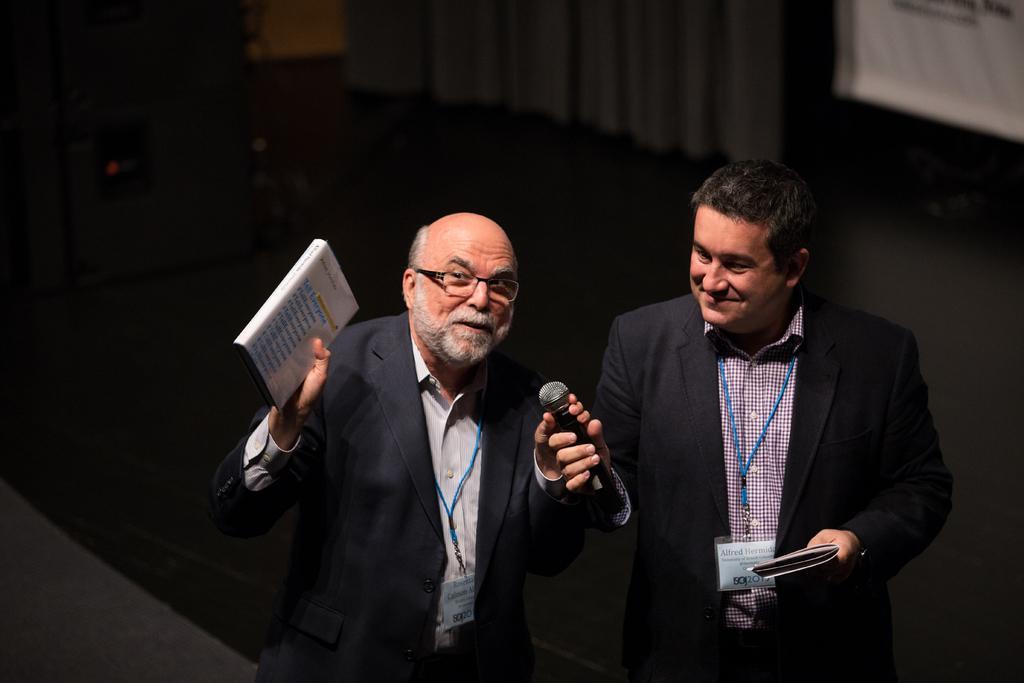Could you give a brief overview of what you see in this image? There is a man who is standing at the center and holding a book in his hand. There is another person who is standing beside a man and he is holding a microphone in his hand and he is smiling. 